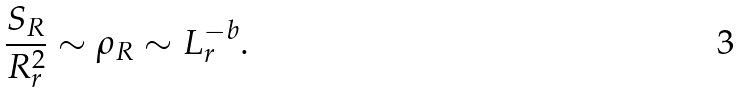<formula> <loc_0><loc_0><loc_500><loc_500>\frac { S _ { R } } { R ^ { 2 } _ { r } } \sim \rho _ { R } \sim L _ { r } ^ { - b } .</formula> 